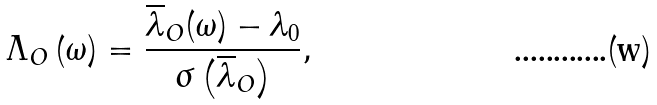<formula> <loc_0><loc_0><loc_500><loc_500>\Lambda _ { O } \left ( \omega \right ) = \frac { \overline { \lambda } _ { O } ( \omega ) - \lambda _ { 0 } } { \sigma \left ( \overline { \lambda } _ { O } \right ) } ,</formula> 